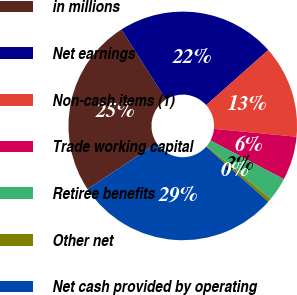Convert chart to OTSL. <chart><loc_0><loc_0><loc_500><loc_500><pie_chart><fcel>in millions<fcel>Net earnings<fcel>Non-cash items (1)<fcel>Trade working capital<fcel>Retiree benefits<fcel>Other net<fcel>Net cash provided by operating<nl><fcel>25.32%<fcel>22.46%<fcel>13.06%<fcel>6.21%<fcel>3.34%<fcel>0.48%<fcel>29.12%<nl></chart> 